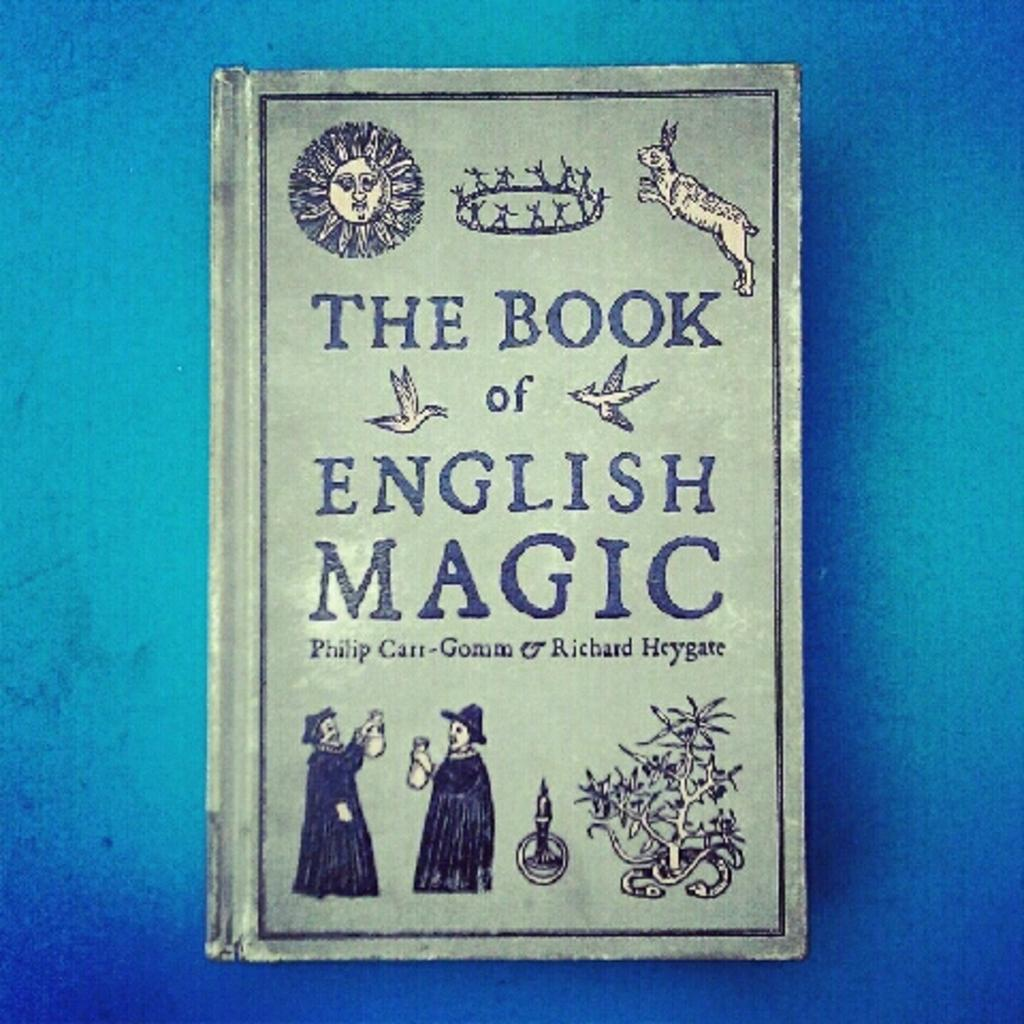What object can be seen in the image? There is a book in the image. Who are the people in the image? There are two persons on the left side of the image. What are the two persons wearing? The two persons are wearing black color dresses. What animal is on the right side of the image? There is a rabbit on the right side of the image. What type of haircut does the rabbit have in the image? There is no haircut to be observed on the rabbit, as rabbits do not have hair that can be cut like humans. 